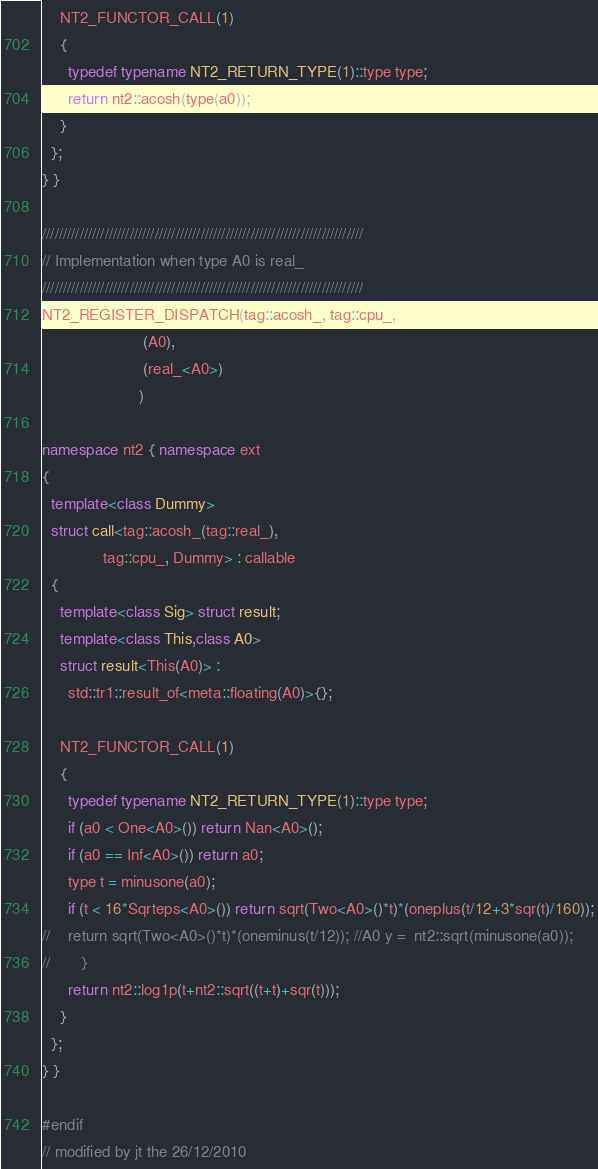Convert code to text. <code><loc_0><loc_0><loc_500><loc_500><_C++_>
    NT2_FUNCTOR_CALL(1)
    {
      typedef typename NT2_RETURN_TYPE(1)::type type;
      return nt2::acosh(type(a0));
    }
  };
} }

/////////////////////////////////////////////////////////////////////////////
// Implementation when type A0 is real_
/////////////////////////////////////////////////////////////////////////////
NT2_REGISTER_DISPATCH(tag::acosh_, tag::cpu_,
                       (A0),
                       (real_<A0>)
                      )

namespace nt2 { namespace ext
{
  template<class Dummy>
  struct call<tag::acosh_(tag::real_),
              tag::cpu_, Dummy> : callable
  {
    template<class Sig> struct result;
    template<class This,class A0>
    struct result<This(A0)> :
      std::tr1::result_of<meta::floating(A0)>{};

    NT2_FUNCTOR_CALL(1)
    {
      typedef typename NT2_RETURN_TYPE(1)::type type;
      if (a0 < One<A0>()) return Nan<A0>();
      if (a0 == Inf<A0>()) return a0;
      type t = minusone(a0);
      if (t < 16*Sqrteps<A0>()) return sqrt(Two<A0>()*t)*(oneplus(t/12+3*sqr(t)/160));
//    return sqrt(Two<A0>()*t)*(oneminus(t/12)); //A0 y =  nt2::sqrt(minusone(a0));
//       }
      return nt2::log1p(t+nt2::sqrt((t+t)+sqr(t)));
    }
  };
} }

#endif
// modified by jt the 26/12/2010
</code> 